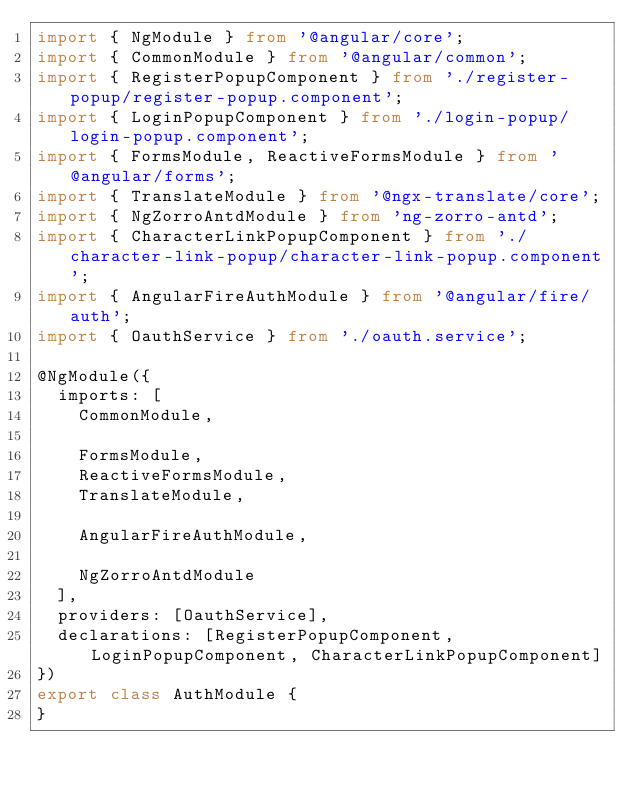<code> <loc_0><loc_0><loc_500><loc_500><_TypeScript_>import { NgModule } from '@angular/core';
import { CommonModule } from '@angular/common';
import { RegisterPopupComponent } from './register-popup/register-popup.component';
import { LoginPopupComponent } from './login-popup/login-popup.component';
import { FormsModule, ReactiveFormsModule } from '@angular/forms';
import { TranslateModule } from '@ngx-translate/core';
import { NgZorroAntdModule } from 'ng-zorro-antd';
import { CharacterLinkPopupComponent } from './character-link-popup/character-link-popup.component';
import { AngularFireAuthModule } from '@angular/fire/auth';
import { OauthService } from './oauth.service';

@NgModule({
  imports: [
    CommonModule,

    FormsModule,
    ReactiveFormsModule,
    TranslateModule,

    AngularFireAuthModule,

    NgZorroAntdModule
  ],
  providers: [OauthService],
  declarations: [RegisterPopupComponent, LoginPopupComponent, CharacterLinkPopupComponent]
})
export class AuthModule {
}
</code> 